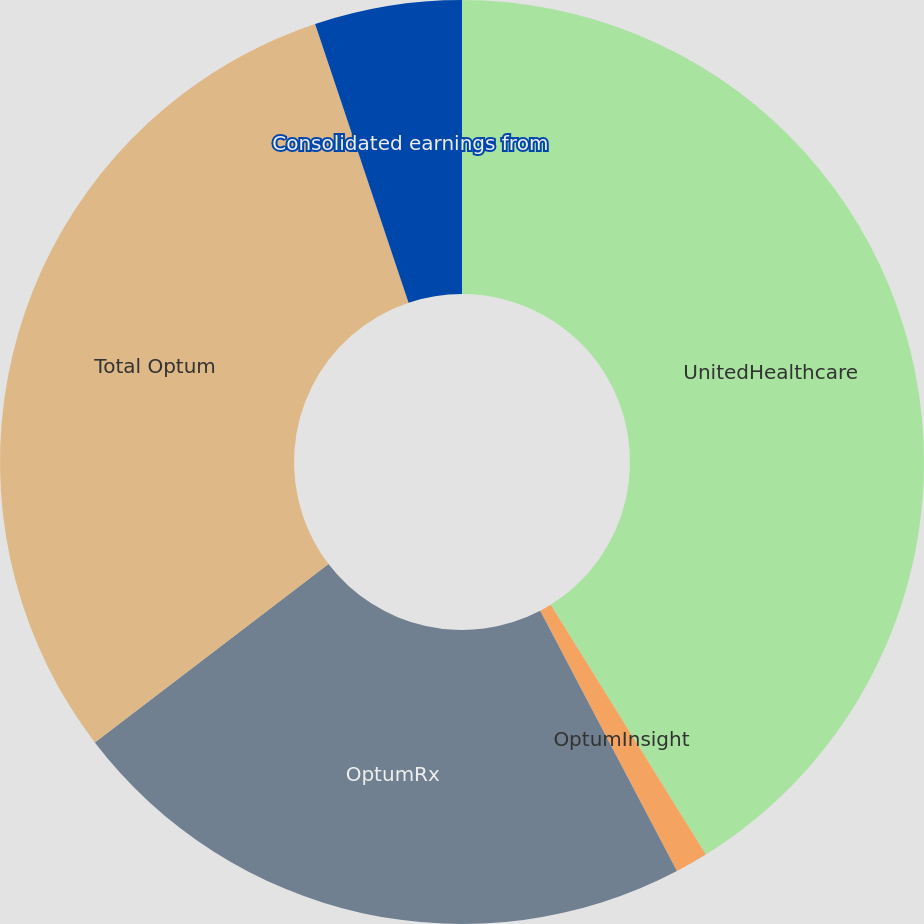Convert chart. <chart><loc_0><loc_0><loc_500><loc_500><pie_chart><fcel>UnitedHealthcare<fcel>OptumInsight<fcel>OptumRx<fcel>Total Optum<fcel>Consolidated earnings from<nl><fcel>41.15%<fcel>1.15%<fcel>22.32%<fcel>30.23%<fcel>5.15%<nl></chart> 